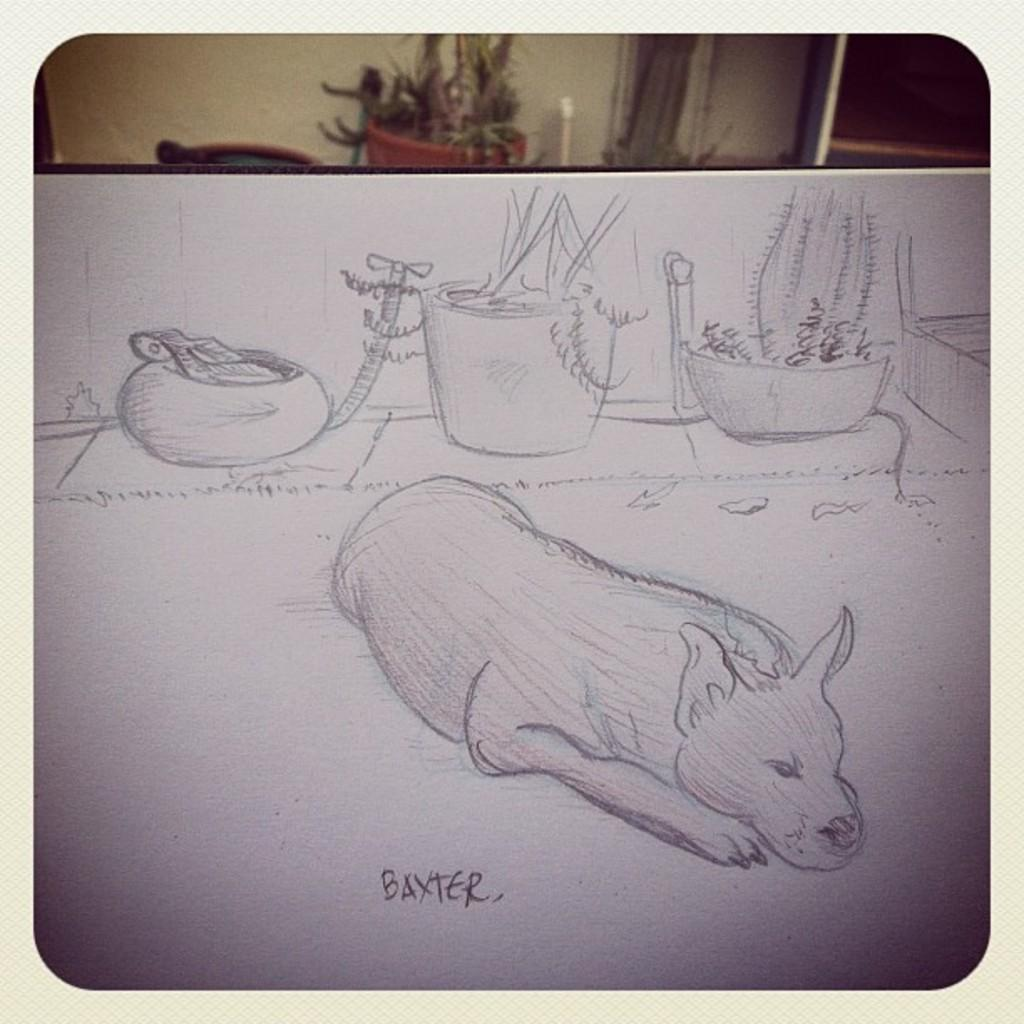What is depicted on the white surface in the image? There is a sketch on a white surface, along with some text. Can you describe the background of the image? There is a wall in the background, as well as a plant in a pot, a pipe, and some other objects. What type of silverware is visible on the table in the image? There is no table or silverware present in the image. 